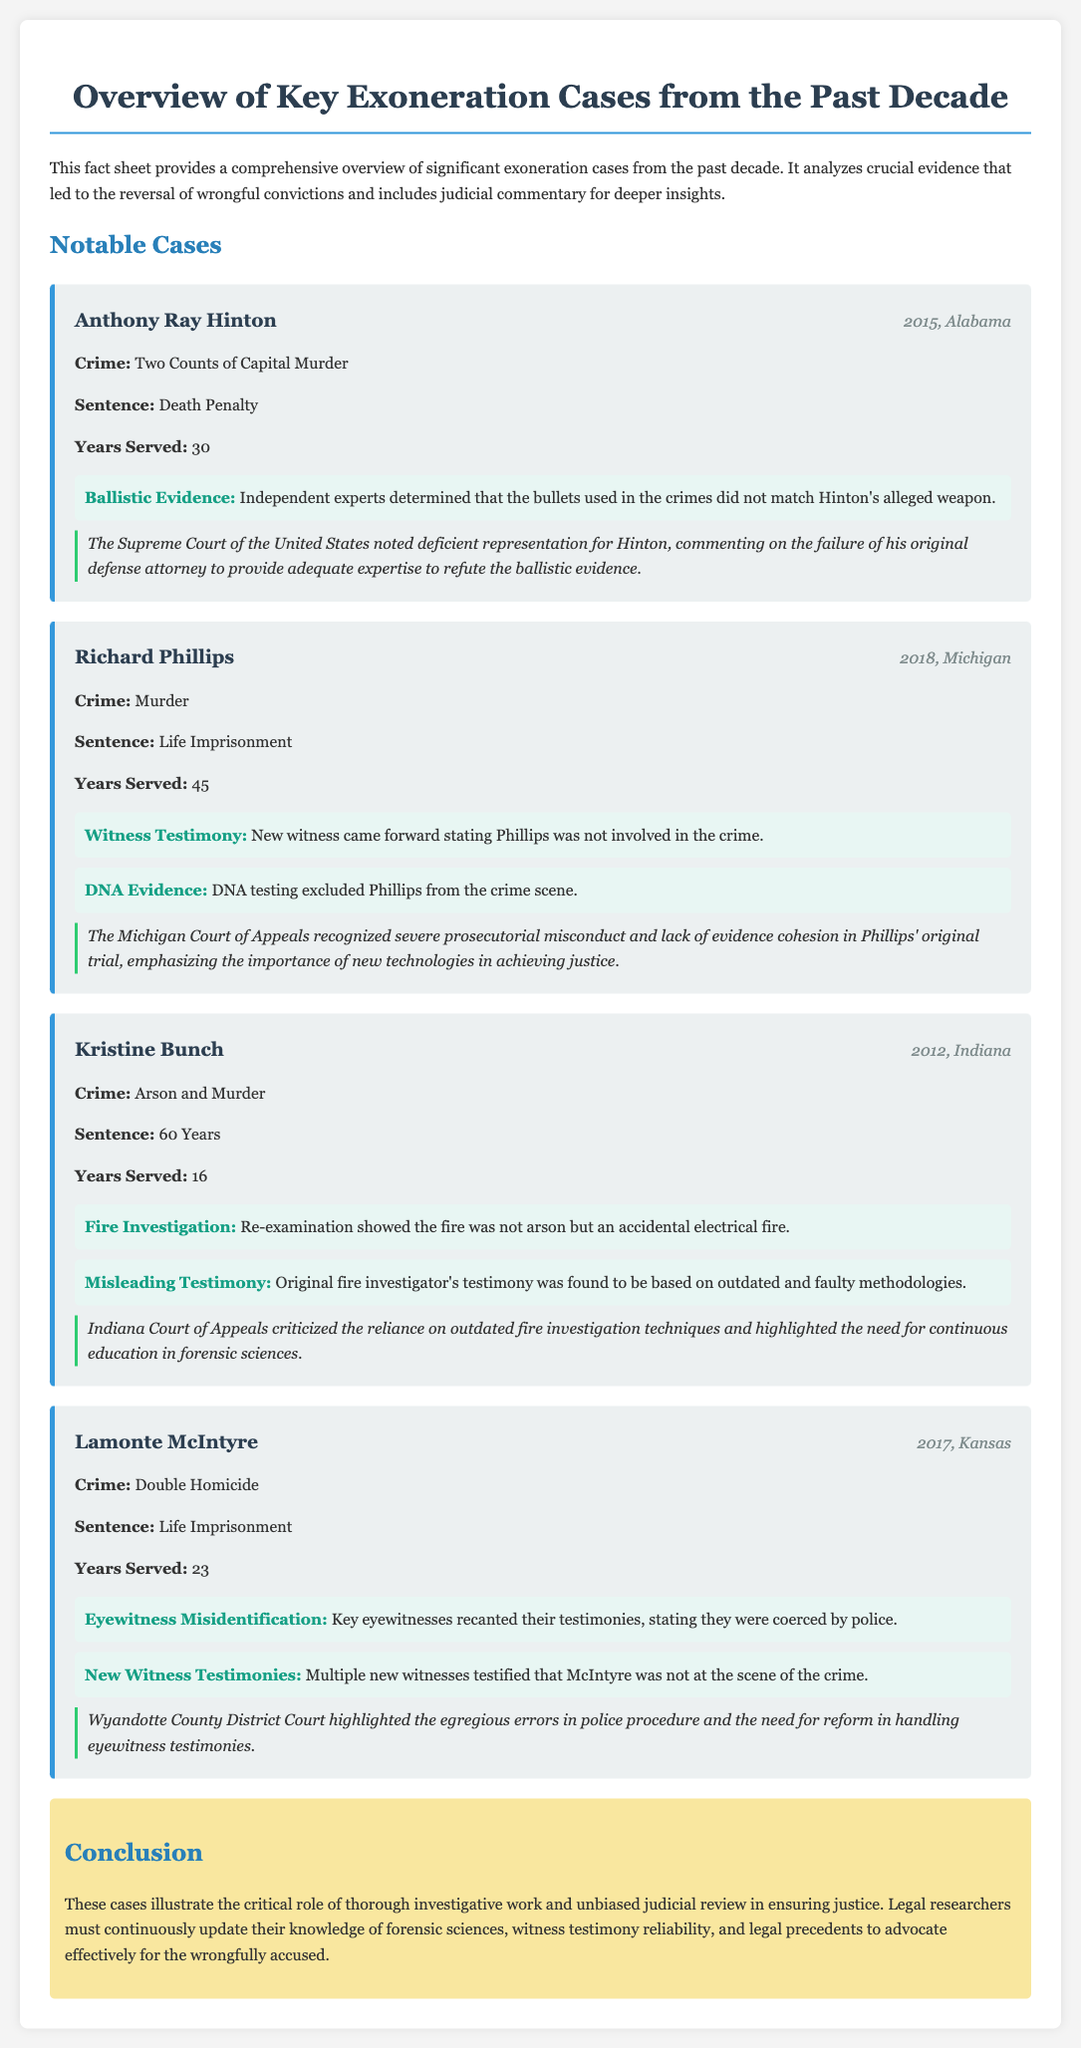What year was Anthony Ray Hinton exonerated? The document states that Anthony Ray Hinton was exonerated in 2015.
Answer: 2015 How many years did Richard Phillips serve in prison? The document indicates that Richard Phillips served 45 years in prison.
Answer: 45 What was Kristine Bunch convicted of? According to the document, Kristine Bunch was convicted of arson and murder.
Answer: Arson and Murder What type of evidence led to Lamonte McIntyre's exoneration? The document mentions eyewitness misidentification and new witness testimonies as the types of evidence for Lamonte McIntyre's exoneration.
Answer: Eyewitness Misidentification, New Witness Testimonies What did the Indiana Court of Appeals criticize in Kristine Bunch's case? The judicial commentary mentions the reliance on outdated fire investigation techniques as a point of criticism by the Indiana Court of Appeals.
Answer: Outdated fire investigation techniques What was a significant factor in the exoneration of Richard Phillips? The document highlights new witness testimony and DNA evidence that excluded Phillips from the crime scene as significant factors.
Answer: New witness testimony, DNA evidence How long did Anthony Ray Hinton serve before exoneration? The document specifies that Anthony Ray Hinton served 30 years before his exoneration.
Answer: 30 years What does the conclusion emphasize about legal research? The conclusion mentions that legal researchers must continuously update their knowledge of forensic sciences and witness testimony reliability.
Answer: Continuous education in forensic sciences, witness testimony reliability 